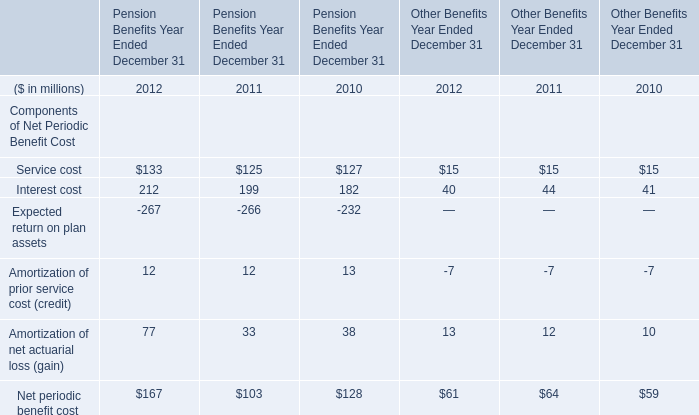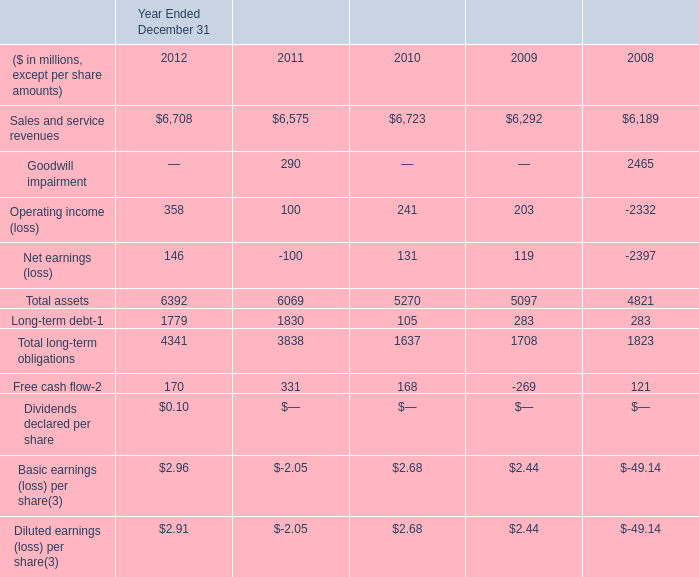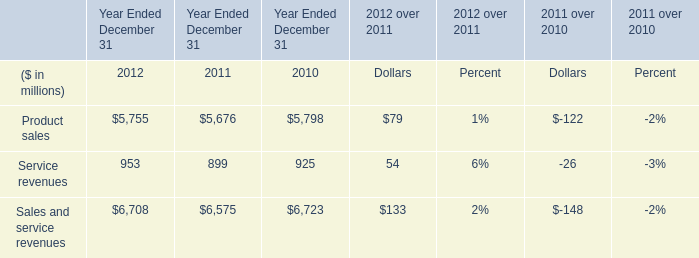How many element continues to decrease each year from 2011 to 2012 for Pension Benefits Year Ended December 31? 
Answer: Service cost and Interest cost and Amortization of net actuarial loss (gain) and Net periodic benefit cost. 